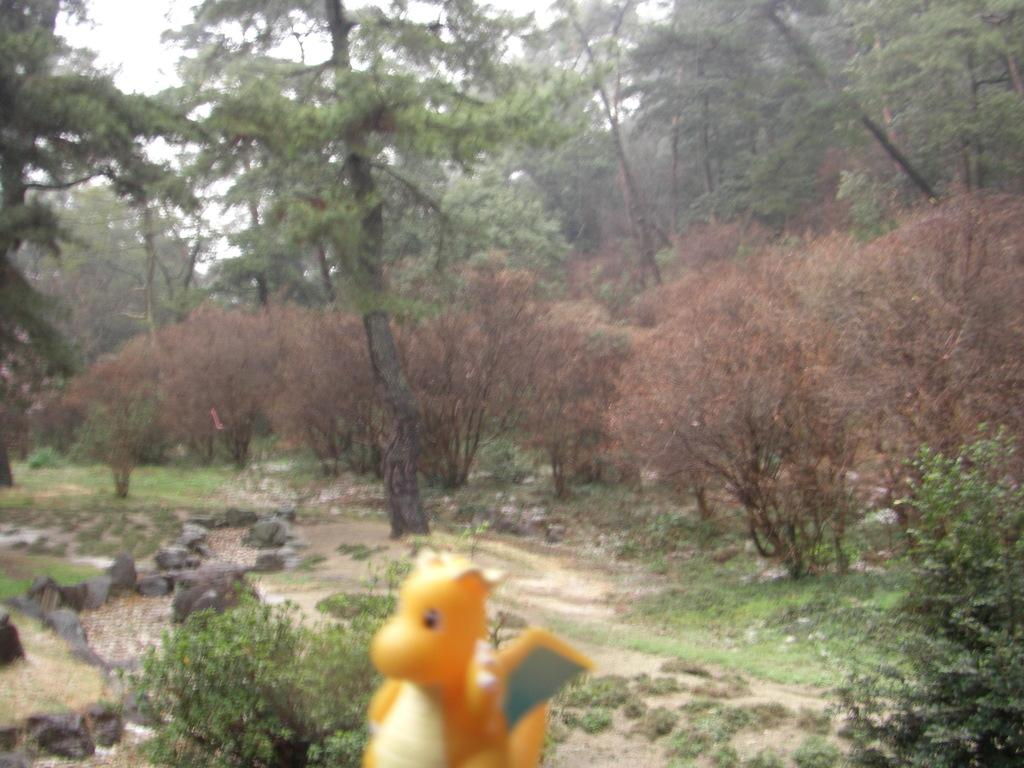What is the color of the toy in the bottom of the picture? The toy in the bottom of the picture is yellow. What can be seen in the background of the image? In the background of the image, there are plants, trees, and the sky. Are there any objects on the left side of the image? Yes, there are some stones on the left side of the image. What type of jewel is being processed by the machine in the image? There is no machine or jewel present in the image. What is the value of the item being displayed in the image? The image does not show any item with a specific value. 